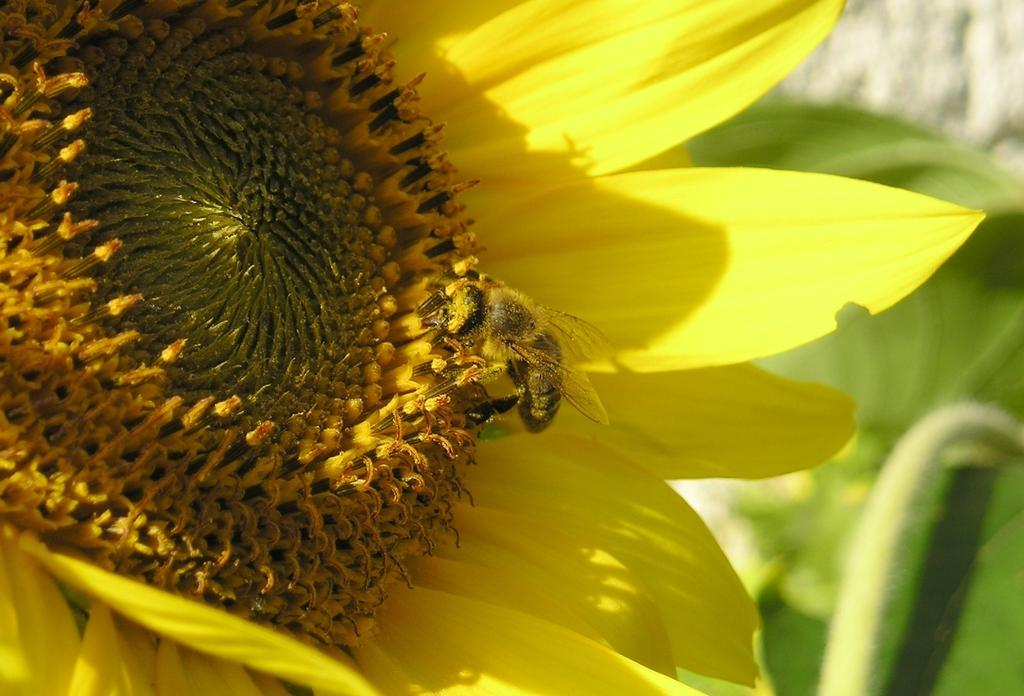What type of plant is featured in the picture? There is a sunflower in the picture. What color are the petals of the sunflower? The sunflower has yellow petals. Is there any wildlife interacting with the sunflower? Yes, there is a bee sitting on the sunflower. What can be seen in the background of the picture? Leaves are visible in the background of the picture. How many lizards can be seen crawling on the glass in the picture? There are no lizards or glass present in the image; it features a sunflower with a bee on it and leaves in the background. 